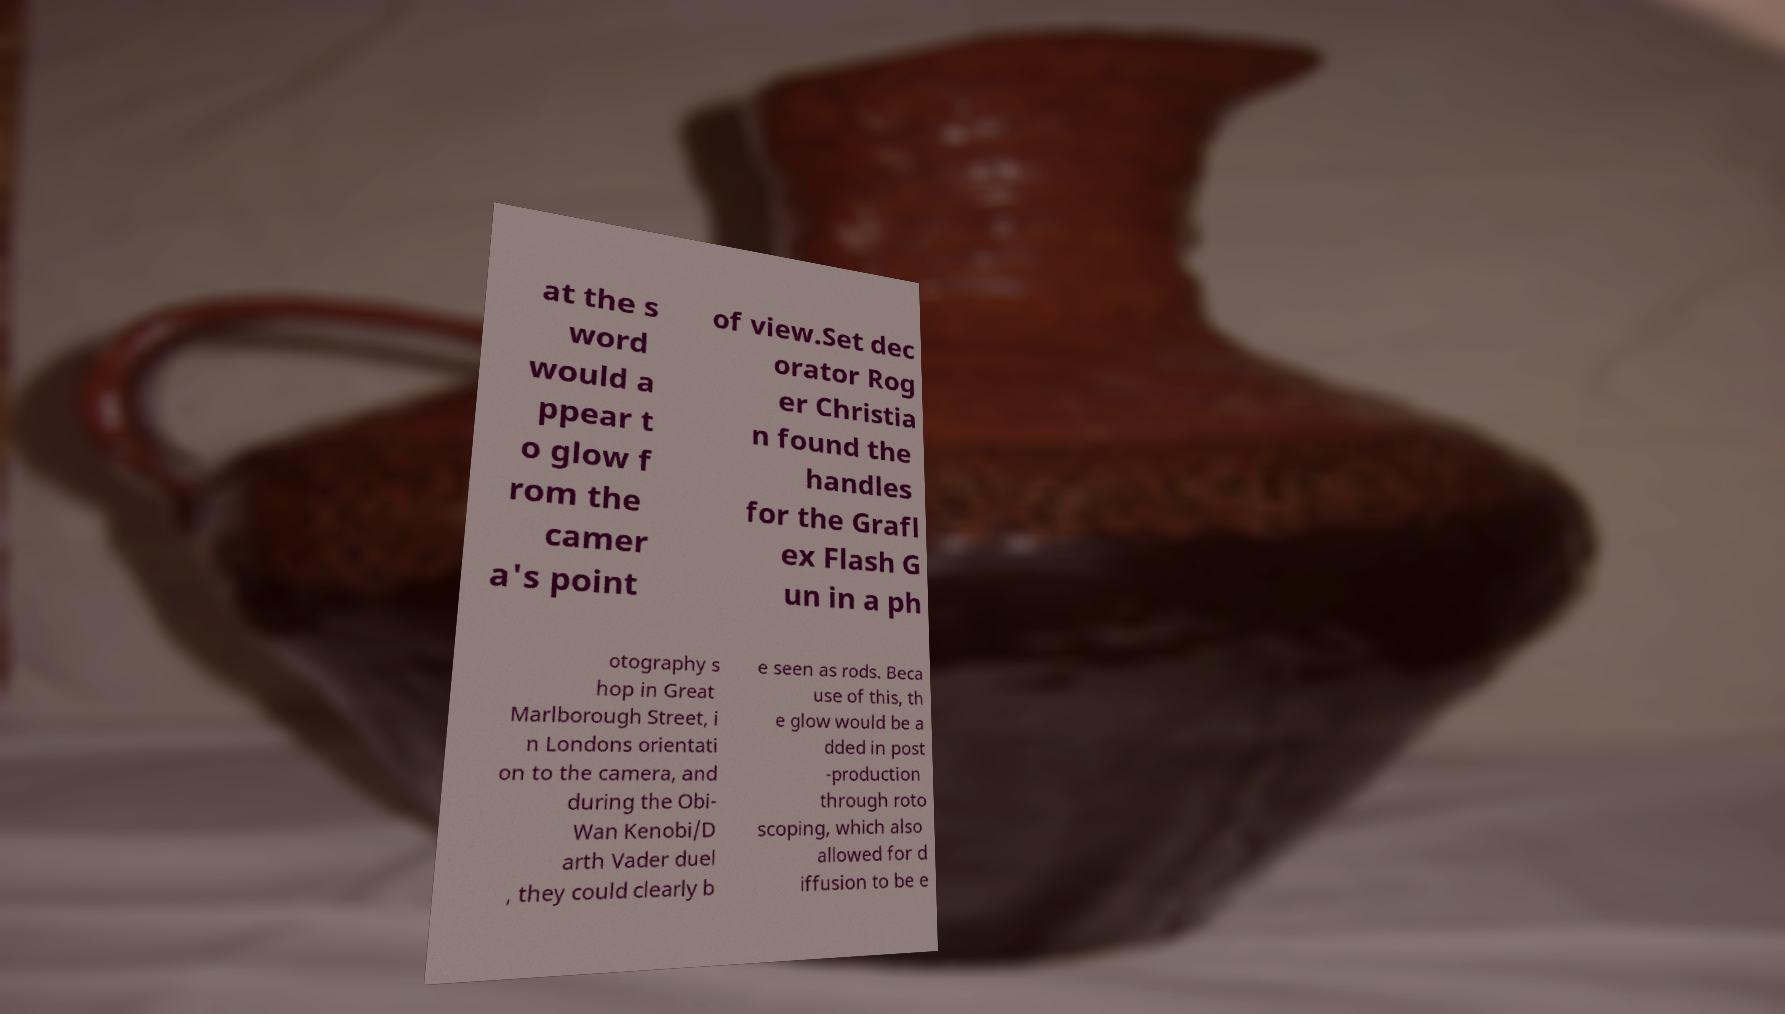I need the written content from this picture converted into text. Can you do that? at the s word would a ppear t o glow f rom the camer a's point of view.Set dec orator Rog er Christia n found the handles for the Grafl ex Flash G un in a ph otography s hop in Great Marlborough Street, i n Londons orientati on to the camera, and during the Obi- Wan Kenobi/D arth Vader duel , they could clearly b e seen as rods. Beca use of this, th e glow would be a dded in post -production through roto scoping, which also allowed for d iffusion to be e 